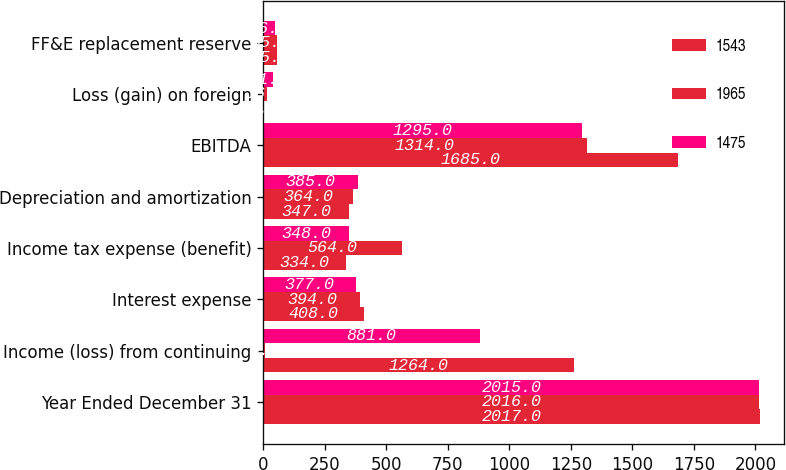Convert chart to OTSL. <chart><loc_0><loc_0><loc_500><loc_500><stacked_bar_chart><ecel><fcel>Year Ended December 31<fcel>Income (loss) from continuing<fcel>Interest expense<fcel>Income tax expense (benefit)<fcel>Depreciation and amortization<fcel>EBITDA<fcel>Loss (gain) on foreign<fcel>FF&E replacement reserve<nl><fcel>1543<fcel>2017<fcel>1264<fcel>408<fcel>334<fcel>347<fcel>1685<fcel>3<fcel>55<nl><fcel>1965<fcel>2016<fcel>8<fcel>394<fcel>564<fcel>364<fcel>1314<fcel>16<fcel>55<nl><fcel>1475<fcel>2015<fcel>881<fcel>377<fcel>348<fcel>385<fcel>1295<fcel>41<fcel>46<nl></chart> 